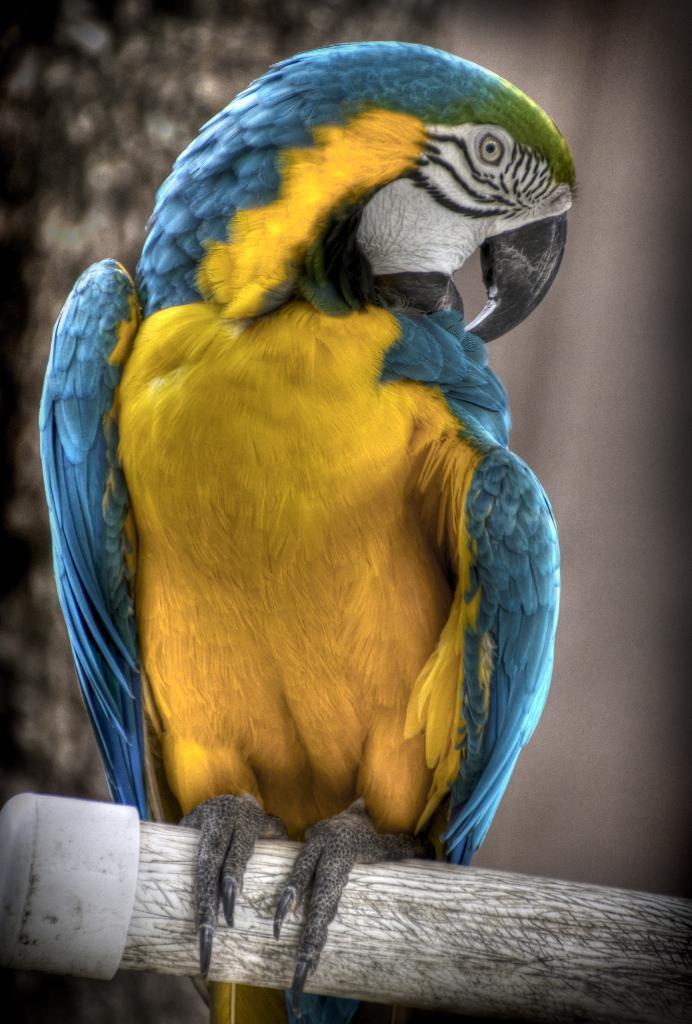Can you describe this image briefly? This is the picture of a bird which is on the wooden stick. 